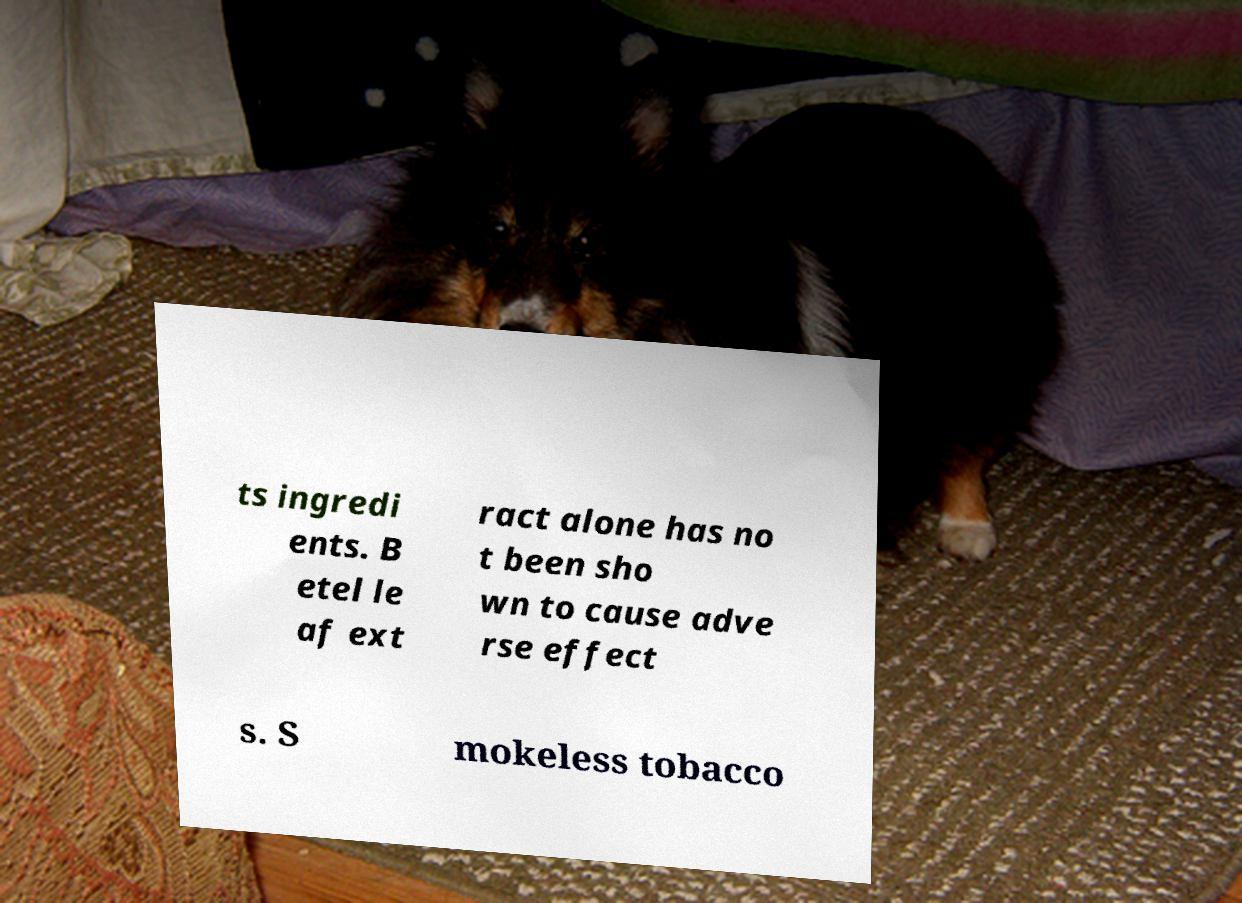Please read and relay the text visible in this image. What does it say? ts ingredi ents. B etel le af ext ract alone has no t been sho wn to cause adve rse effect s. S mokeless tobacco 